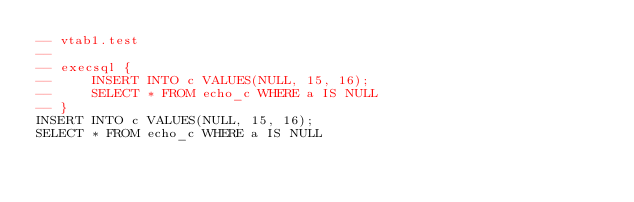<code> <loc_0><loc_0><loc_500><loc_500><_SQL_>-- vtab1.test
-- 
-- execsql { 
--     INSERT INTO c VALUES(NULL, 15, 16);
--     SELECT * FROM echo_c WHERE a IS NULL 
-- }
INSERT INTO c VALUES(NULL, 15, 16);
SELECT * FROM echo_c WHERE a IS NULL</code> 